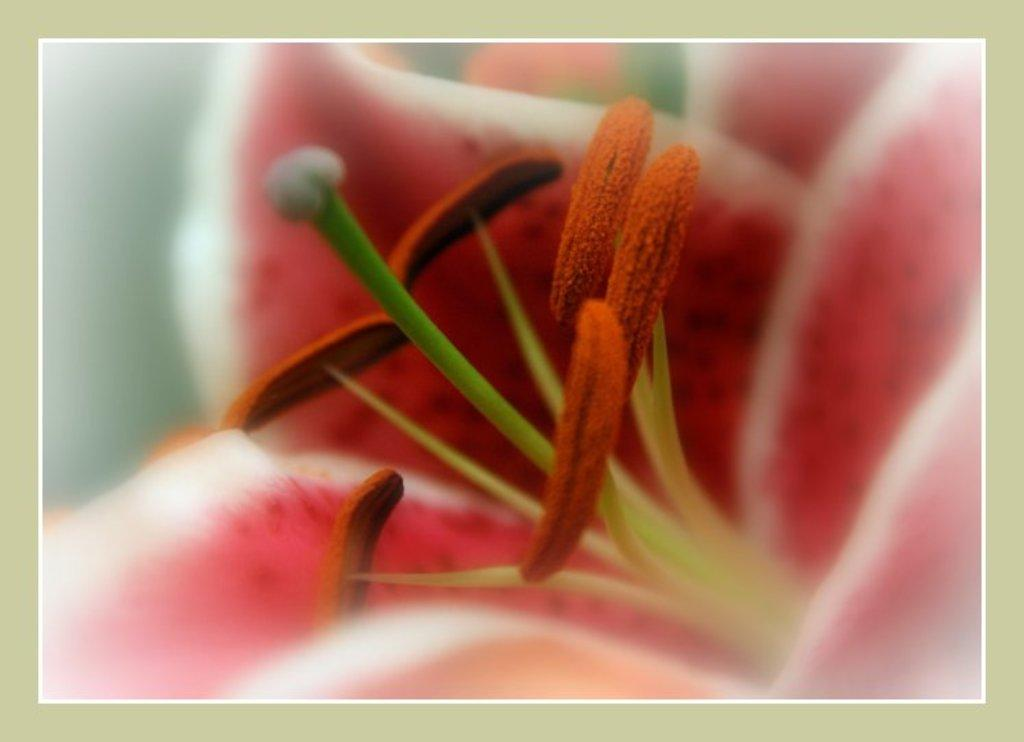What is the main subject of the image? The main subject of the image is a flower. What are the two main parts of the flower's reproductive system? The flower has a stigma and an anther. What colors are the petals of the flower? The petals of the flower are in pink and white colors. Reasoning: Let's think step by step by step in order to produce the conversation. We start by identifying the main subject of the image, which is the flower. Then, we describe the specific parts of the flower that are mentioned in the facts, such as the stigma and anther. Finally, we focus on the appearance of the flower, mentioning the colors of the petals. Absurd Question/Answer: How many pigs are visible in the image? There are no pigs present in the image; it features a flower with petals in pink and white colors. What type of watch is the flower wearing in the image? There is no watch present in the image, as it features a flower with petals in pink and white colors. How many pigs are visible in the image? There are no pigs present in the image; it features a flower with petals in pink and white colors. What type of watch is the flower wearing in the image? There is no watch present in the image, as it features a flower with petals in pink and white colors. 